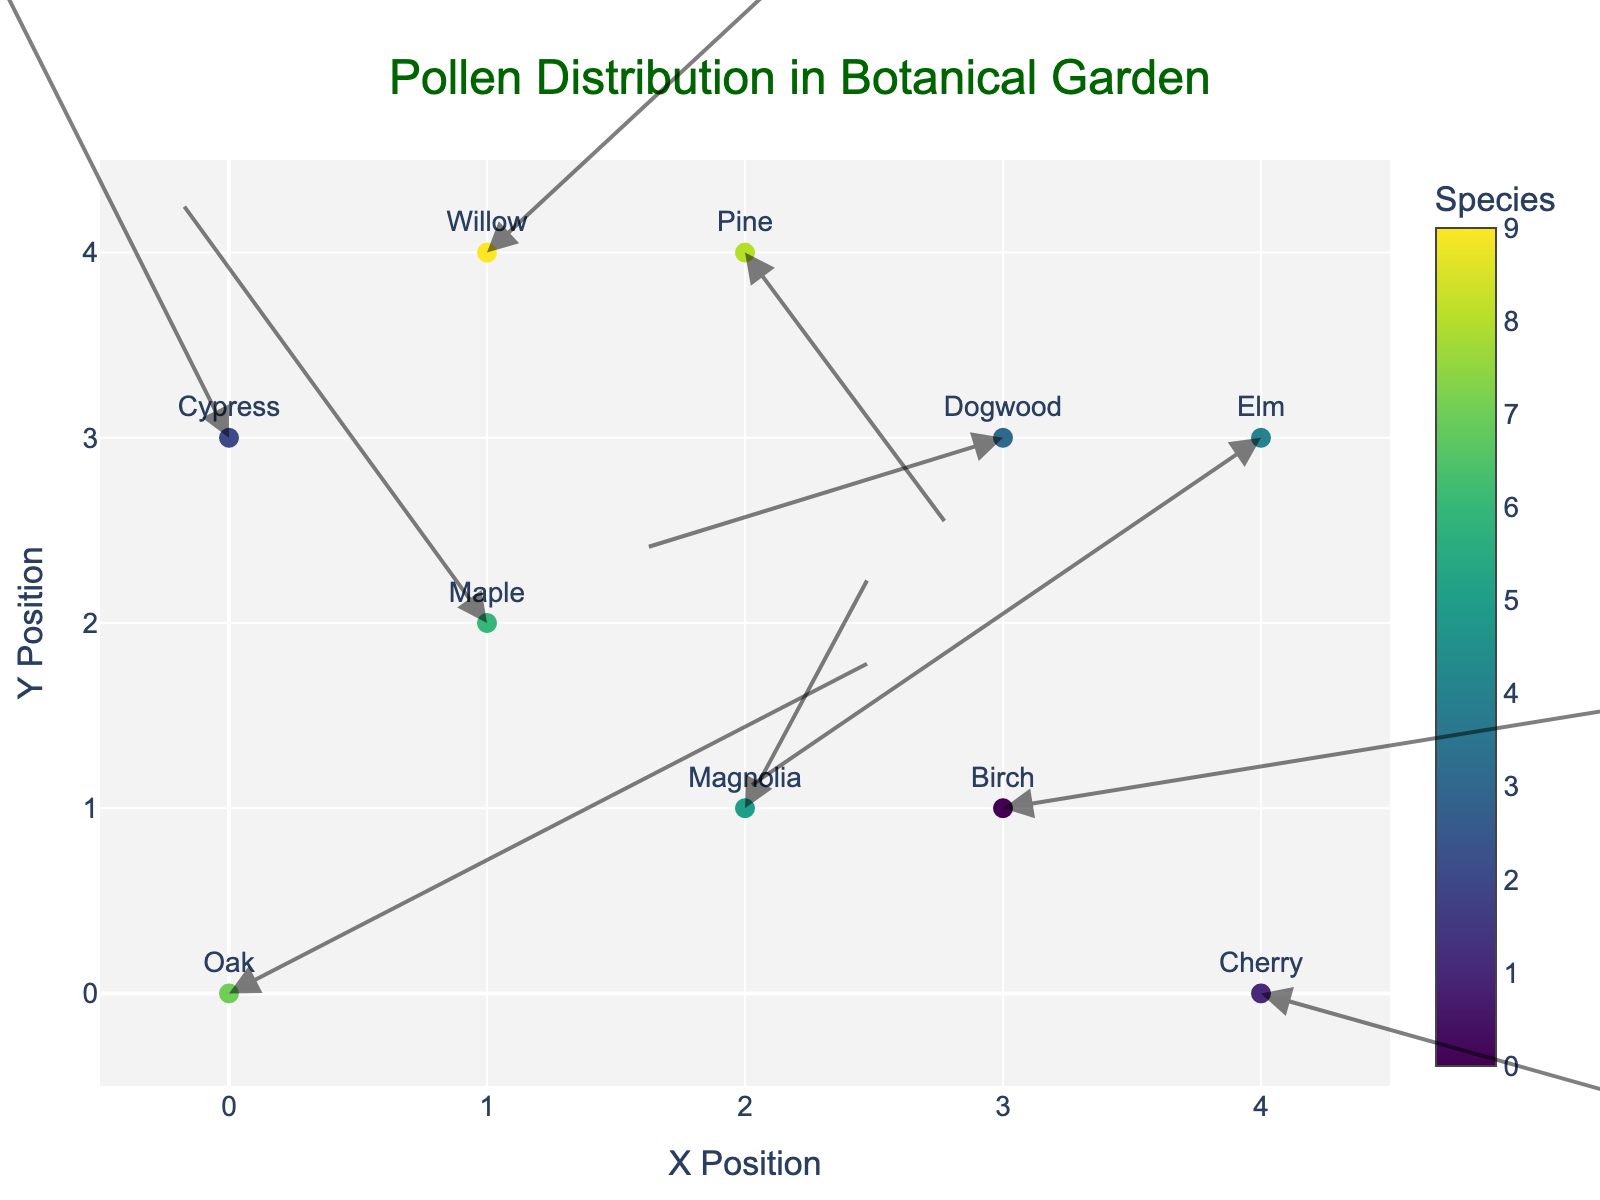What does the title of the figure indicate? The title of the figure is "Pollen Distribution in Botanical Garden" which indicates that the figure is visualizing the distribution of pollen from different plant species based on air currents and wind patterns.
Answer: Pollen Distribution in Botanical Garden How many different plant species are represented in the figure? By examining the different text labels and colors on the markers, we can count the number of unique species names. The figure displays 10 unique species.
Answer: 10 Which species has the vector with the largest magnitude? The magnitude of a vector can be determined by the formula sqrt(u^2 + v^2). Calculating for each vector, the species with the largest magnitude is Dogwood with vector components u = -1.4 and v = -0.6 resulting in a magnitude (sqrt(1.4^2 + 0.6^2)) of approximately 1.52.
Answer: Dogwood Which species is closest to position (2, 2)? By visually inspecting the positions of all species' markers, Maple and Magnolia are the closest to (2, 2). Further assessing their actual distances, Magnolia at (2,1) is closer than Maple at (1,2) either by visual estimation or calculating the Euclidean distances.
Answer: Magnolia Compare the vectors of Oak and Cherry. Which one has a greater horizontal (x) component? By inspecting the table, Oak's horizontal component (u) is 2.5, and Cherry's is 2.8. Cherry has a greater horizontal component.
Answer: Cherry Which data point has the highest vertical component (v)? By examining the vertical component values in the hovertext, Maple has the highest vertical component with v = 2.3.
Answer: Maple What is the average x-position of all the species? Adding all the x positions (0+1+2+3+4+1+3+2+4+0) gives a total of 20. Since there are 10 species, the average x position is 20 / 10 = 2.0.
Answer: 2.0 What is the direction of the vector at the origin (0, 0)? The vector at the origin corresponds to Oak. Its direction is given by its components (u, v) = (2.5, 1.8). To state the direction in degrees, we can calculate the angle using arctan(1.8/2.5). However, referring directly to the visual or vector components, it points approximately towards the top-right.
Answer: Top-right Which species exhibits a vector pointing downwards (negative vertical component)? Inspecting the vectors and their vertical components, both Pine, Elm, and Cherry have negative vertical components. These species exhibit vectors pointing downwards.
Answer: Pine, Elm, Cherry Does Cypress have a positive or negative horizontal component? By looking at the hovertext and table, Cypress has a horizontal component (u) of -0.9, which is negative.
Answer: Negative 